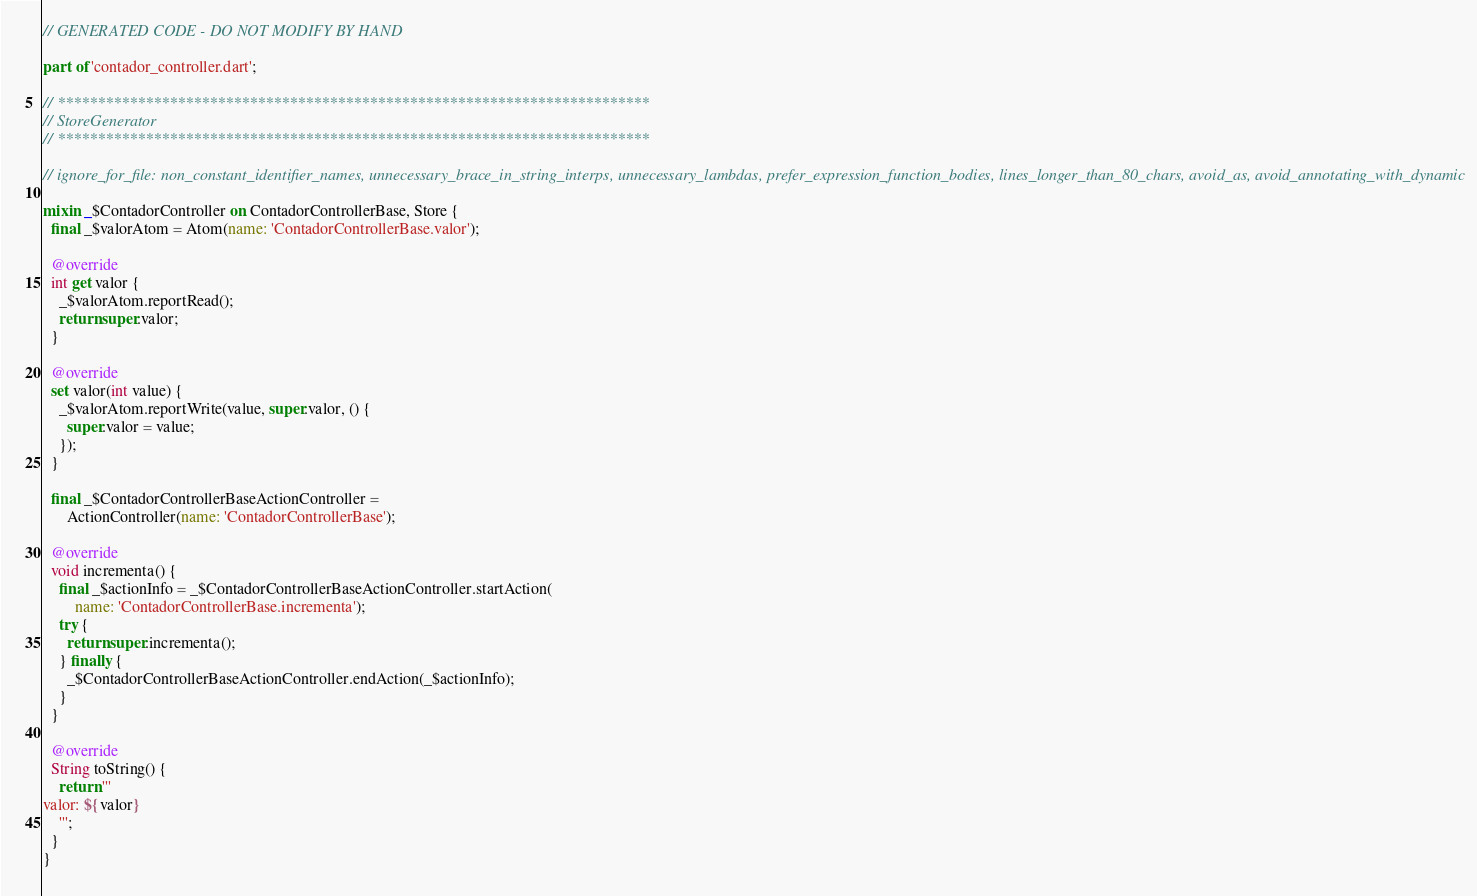Convert code to text. <code><loc_0><loc_0><loc_500><loc_500><_Dart_>// GENERATED CODE - DO NOT MODIFY BY HAND

part of 'contador_controller.dart';

// **************************************************************************
// StoreGenerator
// **************************************************************************

// ignore_for_file: non_constant_identifier_names, unnecessary_brace_in_string_interps, unnecessary_lambdas, prefer_expression_function_bodies, lines_longer_than_80_chars, avoid_as, avoid_annotating_with_dynamic

mixin _$ContadorController on ContadorControllerBase, Store {
  final _$valorAtom = Atom(name: 'ContadorControllerBase.valor');

  @override
  int get valor {
    _$valorAtom.reportRead();
    return super.valor;
  }

  @override
  set valor(int value) {
    _$valorAtom.reportWrite(value, super.valor, () {
      super.valor = value;
    });
  }

  final _$ContadorControllerBaseActionController =
      ActionController(name: 'ContadorControllerBase');

  @override
  void incrementa() {
    final _$actionInfo = _$ContadorControllerBaseActionController.startAction(
        name: 'ContadorControllerBase.incrementa');
    try {
      return super.incrementa();
    } finally {
      _$ContadorControllerBaseActionController.endAction(_$actionInfo);
    }
  }

  @override
  String toString() {
    return '''
valor: ${valor}
    ''';
  }
}
</code> 